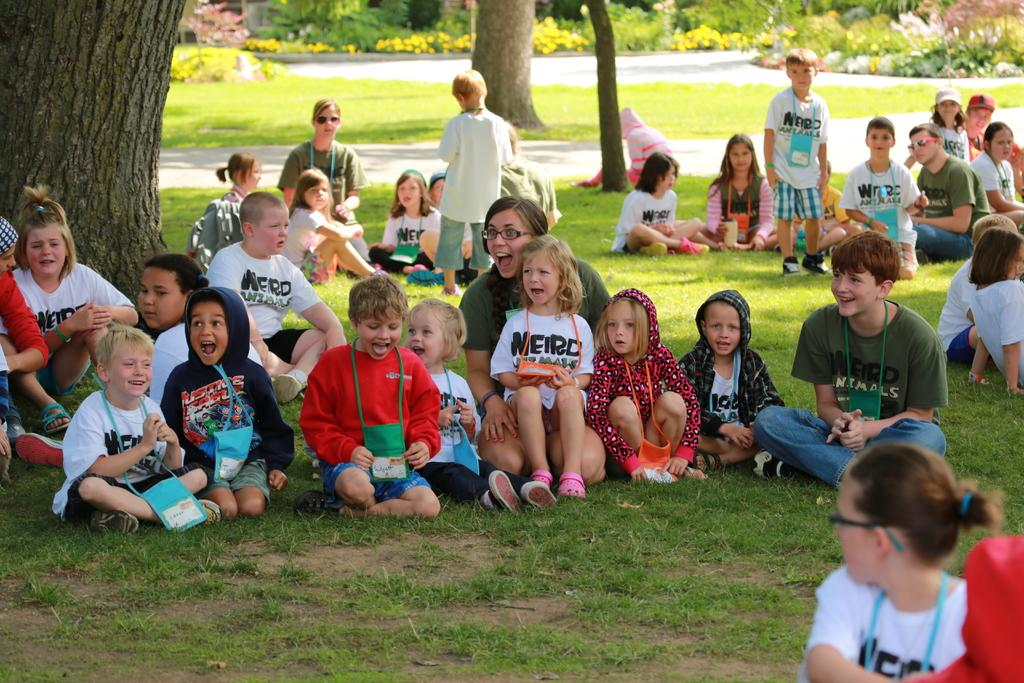What is the primary subject of the image? The primary subject of the image is children. What are some people in the image doing? Some people are sitting on the grass. What are the children in the image doing? Some children are standing. What can be seen in the background of the image? There are trees and shrubs in the background of the image. How many cannons are visible in the image? There are no cannons present in the image. What is the name of the girl in the image? There is no specific girl mentioned in the image, and we cannot determine individual names from the image alone. 